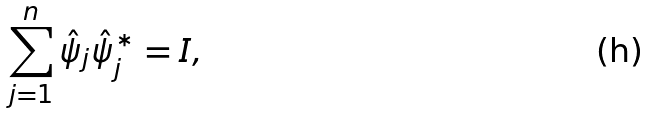Convert formula to latex. <formula><loc_0><loc_0><loc_500><loc_500>\sum _ { j = 1 } ^ { n } \hat { \psi } _ { j } \hat { \psi } _ { j } ^ { * } = I ,</formula> 